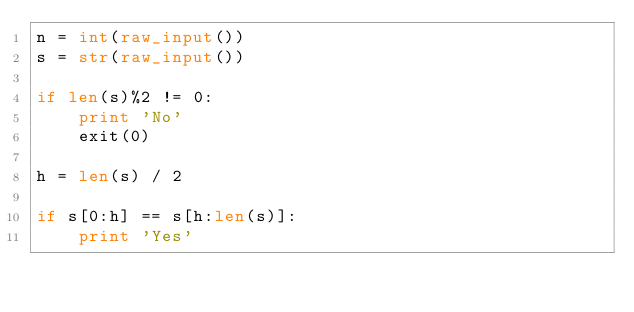Convert code to text. <code><loc_0><loc_0><loc_500><loc_500><_Python_>n = int(raw_input())
s = str(raw_input())

if len(s)%2 != 0:
    print 'No'
    exit(0)

h = len(s) / 2

if s[0:h] == s[h:len(s)]:
    print 'Yes'

</code> 